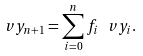Convert formula to latex. <formula><loc_0><loc_0><loc_500><loc_500>\ v y _ { n + 1 } = \sum _ { i = 0 } ^ { n } f _ { i } \, \ v y _ { i } .</formula> 